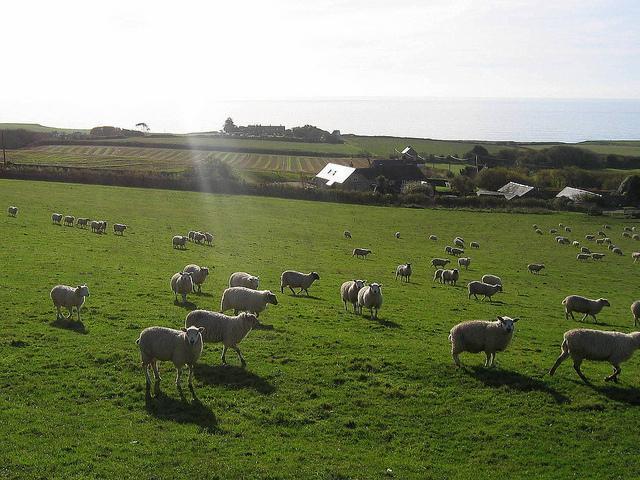What type of worker would be found here?
Select the accurate response from the four choices given to answer the question.
Options: Farmer, dentist, judge, doctor. Farmer. 